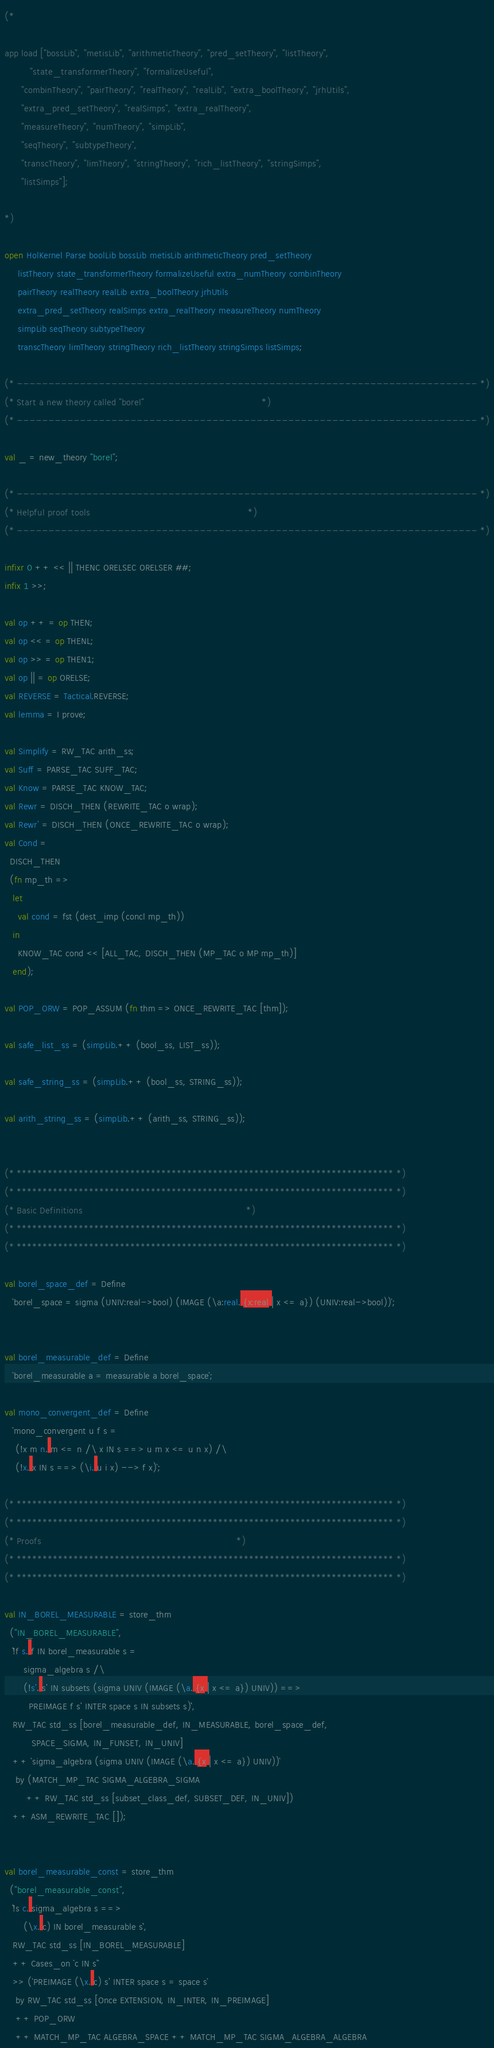Convert code to text. <code><loc_0><loc_0><loc_500><loc_500><_SML_>(*

app load ["bossLib", "metisLib", "arithmeticTheory", "pred_setTheory", "listTheory",
   	  "state_transformerTheory", "formalizeUseful",
	  "combinTheory", "pairTheory", "realTheory", "realLib", "extra_boolTheory", "jrhUtils",
	  "extra_pred_setTheory", "realSimps", "extra_realTheory",
	  "measureTheory", "numTheory", "simpLib",
	  "seqTheory", "subtypeTheory",
	  "transcTheory", "limTheory", "stringTheory", "rich_listTheory", "stringSimps",
	  "listSimps"];

*)

open HolKernel Parse boolLib bossLib metisLib arithmeticTheory pred_setTheory
     listTheory state_transformerTheory formalizeUseful extra_numTheory combinTheory
     pairTheory realTheory realLib extra_boolTheory jrhUtils
     extra_pred_setTheory realSimps extra_realTheory measureTheory numTheory
     simpLib seqTheory subtypeTheory
     transcTheory limTheory stringTheory rich_listTheory stringSimps listSimps;

(* ------------------------------------------------------------------------- *)
(* Start a new theory called "borel"                                         *)
(* ------------------------------------------------------------------------- *)

val _ = new_theory "borel";

(* ------------------------------------------------------------------------- *)
(* Helpful proof tools                                                       *)
(* ------------------------------------------------------------------------- *)

infixr 0 ++ << || THENC ORELSEC ORELSER ##;
infix 1 >>;

val op ++ = op THEN;
val op << = op THENL;
val op >> = op THEN1;
val op || = op ORELSE;
val REVERSE = Tactical.REVERSE;
val lemma = I prove;

val Simplify = RW_TAC arith_ss;
val Suff = PARSE_TAC SUFF_TAC;
val Know = PARSE_TAC KNOW_TAC;
val Rewr = DISCH_THEN (REWRITE_TAC o wrap);
val Rewr' = DISCH_THEN (ONCE_REWRITE_TAC o wrap);
val Cond =
  DISCH_THEN
  (fn mp_th =>
   let
     val cond = fst (dest_imp (concl mp_th))
   in
     KNOW_TAC cond << [ALL_TAC, DISCH_THEN (MP_TAC o MP mp_th)]
   end);

val POP_ORW = POP_ASSUM (fn thm => ONCE_REWRITE_TAC [thm]);

val safe_list_ss = (simpLib.++ (bool_ss, LIST_ss));

val safe_string_ss = (simpLib.++ (bool_ss, STRING_ss));

val arith_string_ss = (simpLib.++ (arith_ss, STRING_ss));


(* ************************************************************************* *)
(* ************************************************************************* *)
(* Basic Definitions                                                         *)
(* ************************************************************************* *)
(* ************************************************************************* *)

val borel_space_def = Define
   `borel_space = sigma (UNIV:real->bool) (IMAGE (\a:real. {x:real | x <= a}) (UNIV:real->bool))`;


val borel_measurable_def = Define
   `borel_measurable a = measurable a borel_space`;

val mono_convergent_def = Define
   `mono_convergent u f s =
	(!x m n. m <= n /\ x IN s ==> u m x <= u n x) /\
	(!x. x IN s ==> (\i. u i x) --> f x)`;

(* ************************************************************************* *)
(* ************************************************************************* *)
(* Proofs                                                                    *)
(* ************************************************************************* *)
(* ************************************************************************* *)

val IN_BOREL_MEASURABLE = store_thm
  ("IN_BOREL_MEASURABLE",
   ``!f s. f IN borel_measurable s =
	   sigma_algebra s /\
	   (!s'. s' IN subsets (sigma UNIV (IMAGE (\a. {x | x <= a}) UNIV)) ==>
		 PREIMAGE f s' INTER space s IN subsets s)``,
   RW_TAC std_ss [borel_measurable_def, IN_MEASURABLE, borel_space_def,
		  SPACE_SIGMA, IN_FUNSET, IN_UNIV]
   ++ `sigma_algebra (sigma UNIV (IMAGE (\a. {x | x <= a}) UNIV))`
	by (MATCH_MP_TAC SIGMA_ALGEBRA_SIGMA
	    ++ RW_TAC std_ss [subset_class_def, SUBSET_DEF, IN_UNIV])
   ++ ASM_REWRITE_TAC []);


val borel_measurable_const = store_thm
  ("borel_measurable_const",
   ``!s c. sigma_algebra s ==>
	   (\x. c) IN borel_measurable s``,
   RW_TAC std_ss [IN_BOREL_MEASURABLE]
   ++ Cases_on `c IN s'`
   >> (`PREIMAGE (\x. c) s' INTER space s = space s`
	by RW_TAC std_ss [Once EXTENSION, IN_INTER, IN_PREIMAGE]
	++ POP_ORW
	++ MATCH_MP_TAC ALGEBRA_SPACE ++ MATCH_MP_TAC SIGMA_ALGEBRA_ALGEBRA</code> 